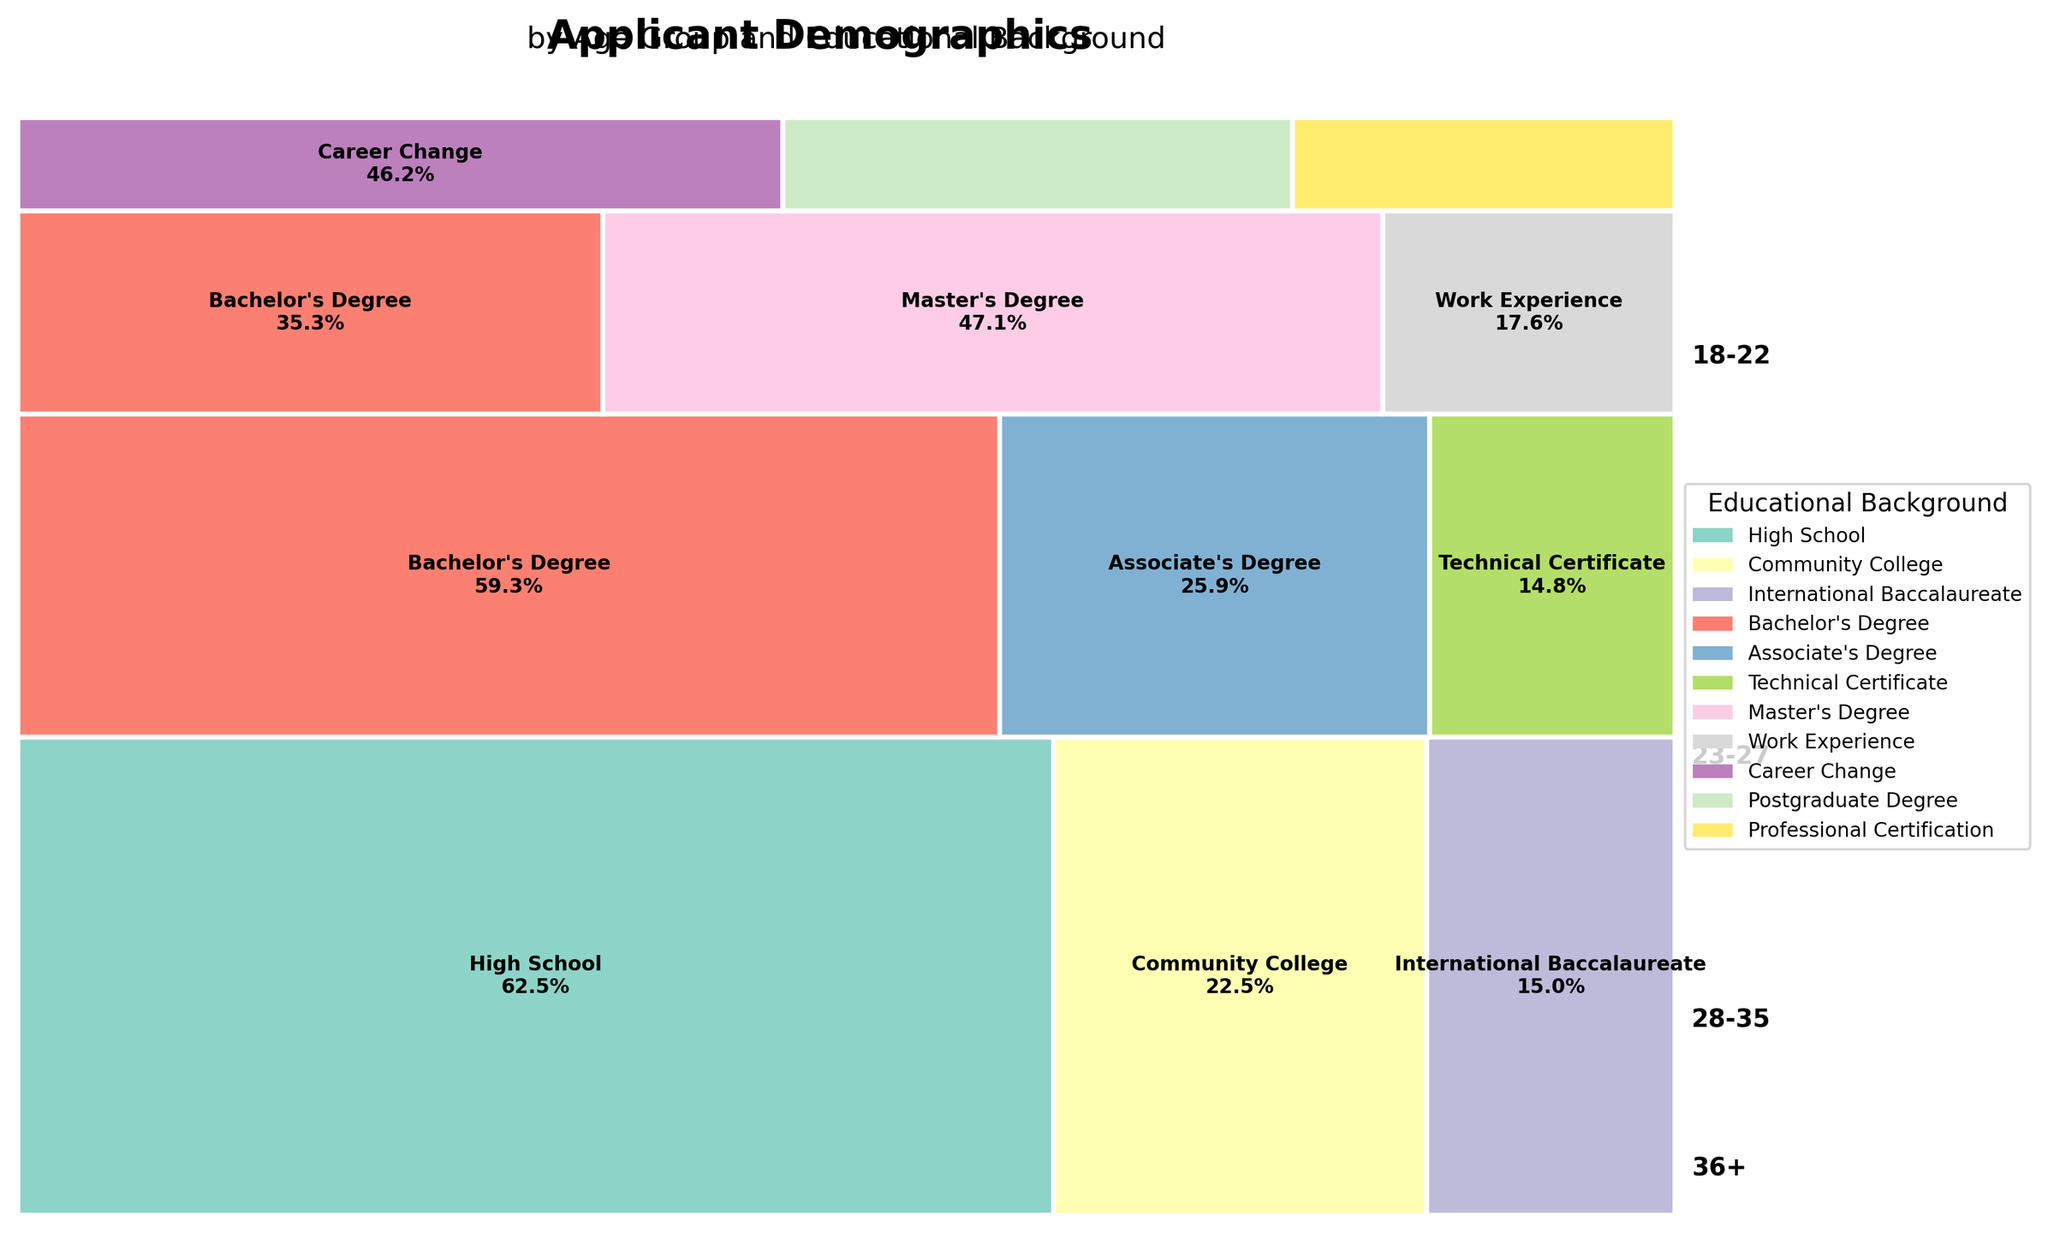What's the title of the figure? The title of the figure is located at the top of the mosaic plot. It usually provides a summary of the content being visualized. The title here is "Applicant Demographics by Age Group and Educational Background".
Answer: Applicant Demographics by Age Group and Educational Background Which age group has the largest representation in the plot? To find the age group with the largest representation, look at the areas of the rectangles from top to bottom. The age group with the tallest total height is "18-22".
Answer: 18-22 How does the representation of individuals with a Bachelor's Degree change between age groups? To assess the change, find the rectangles for "Bachelor's Degree" within each age group and compare their sizes. The "Bachelor’s Degree" segment is visible in both "23-27" and "28-35" groups. The segment in "23-27" is larger than the one in "28-35".
Answer: Larger in 23-27 than in 28-35 What is the proportion of applicants aged 18-22 with a Community College background? Identify the "Community College" rectangle within the "18-22" age group and look for the text stating the percentage. The proportion is displayed as approximately 450 out of 2000, which is 450/2000 or 22.5%.
Answer: 22.5% Which age group has the smallest segment labeled "Work Experience"? Look for "Work Experience" segments across all age groups and compare their sizes. This segment is present in "28-35" and is absent in others. The rectangle is relatively small.
Answer: 28-35 Among the "36+" age group, which educational background is least represented? Investigate the rectangles within the "36+" age group and find the smallest one. The "Professional Certification" background has the smallest segment in this group.
Answer: Professional Certification Compare the representation of "Technical Certificate" in the age groups "23-27" and "28-35". Locate the "Technical Certificate" rectangles in both age groups. This rectangle appears in "23-27" but is not present in "28-35." So it is zero in "28-35".
Answer: Present in 23-27, Absent in 28-35 What is the total number of educational categories represented in the age group "23-27"? Count the distinct educational background rectangles within the age group "23-27". They are "Bachelor's Degree," "Associate's Degree," and "Technical Certificate," making a total of three.
Answer: 3 Which educational background is most diversified across different age groups? Examine the plot for the educational background that appears in the largest number of different age groups. "Bachelor's Degree" appears in both "23-27" and "28-35" age groups.
Answer: Bachelor's Degree 